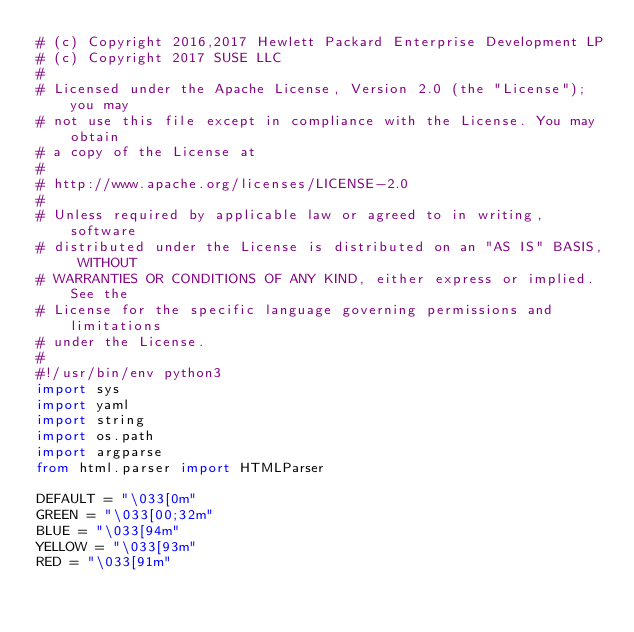Convert code to text. <code><loc_0><loc_0><loc_500><loc_500><_Python_># (c) Copyright 2016,2017 Hewlett Packard Enterprise Development LP
# (c) Copyright 2017 SUSE LLC
#
# Licensed under the Apache License, Version 2.0 (the "License"); you may
# not use this file except in compliance with the License. You may obtain
# a copy of the License at
#
# http://www.apache.org/licenses/LICENSE-2.0
#
# Unless required by applicable law or agreed to in writing, software
# distributed under the License is distributed on an "AS IS" BASIS, WITHOUT
# WARRANTIES OR CONDITIONS OF ANY KIND, either express or implied. See the
# License for the specific language governing permissions and limitations
# under the License.
#
#!/usr/bin/env python3
import sys
import yaml
import string
import os.path
import argparse
from html.parser import HTMLParser

DEFAULT = "\033[0m"
GREEN = "\033[00;32m"
BLUE = "\033[94m"
YELLOW = "\033[93m"
RED = "\033[91m"
</code> 